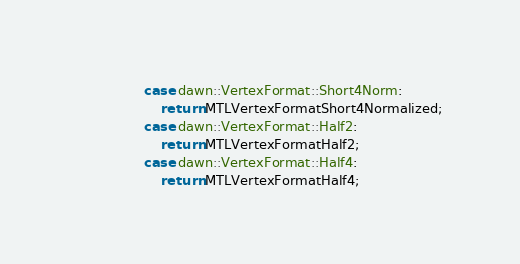Convert code to text. <code><loc_0><loc_0><loc_500><loc_500><_ObjectiveC_>                case dawn::VertexFormat::Short4Norm:
                    return MTLVertexFormatShort4Normalized;
                case dawn::VertexFormat::Half2:
                    return MTLVertexFormatHalf2;
                case dawn::VertexFormat::Half4:
                    return MTLVertexFormatHalf4;</code> 